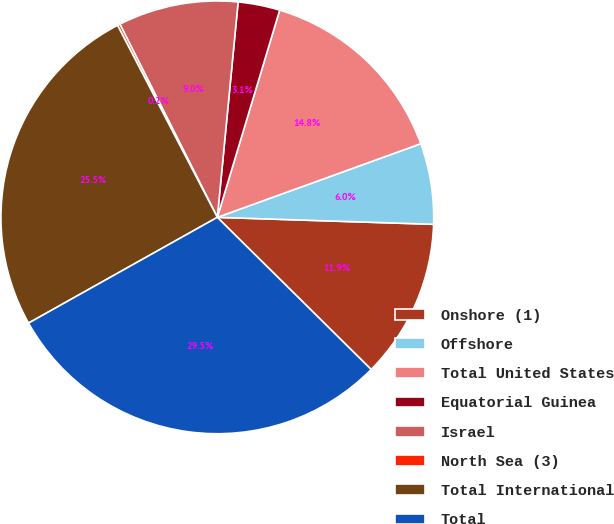Convert chart to OTSL. <chart><loc_0><loc_0><loc_500><loc_500><pie_chart><fcel>Onshore (1)<fcel>Offshore<fcel>Total United States<fcel>Equatorial Guinea<fcel>Israel<fcel>North Sea (3)<fcel>Total International<fcel>Total<nl><fcel>11.9%<fcel>6.04%<fcel>14.82%<fcel>3.12%<fcel>8.97%<fcel>0.19%<fcel>25.5%<fcel>29.46%<nl></chart> 